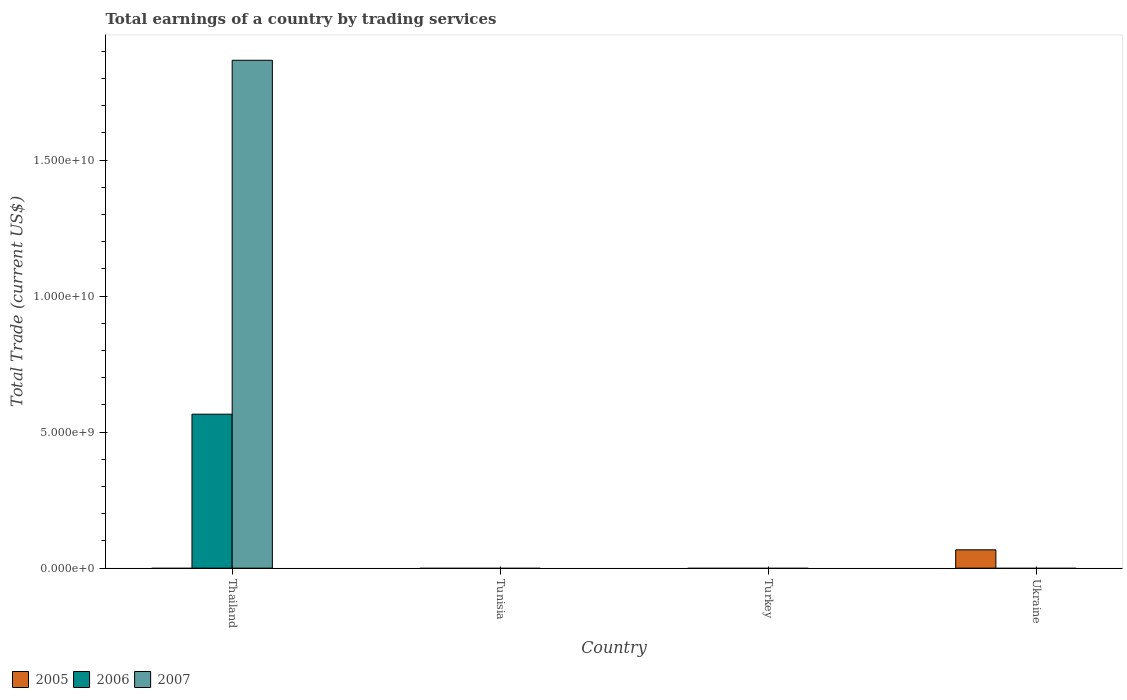How many different coloured bars are there?
Ensure brevity in your answer.  3. Are the number of bars per tick equal to the number of legend labels?
Your response must be concise. No. Are the number of bars on each tick of the X-axis equal?
Keep it short and to the point. No. How many bars are there on the 3rd tick from the left?
Provide a short and direct response. 0. How many bars are there on the 3rd tick from the right?
Your response must be concise. 0. What is the label of the 2nd group of bars from the left?
Your answer should be compact. Tunisia. What is the total earnings in 2005 in Ukraine?
Make the answer very short. 6.74e+08. Across all countries, what is the maximum total earnings in 2007?
Make the answer very short. 1.87e+1. Across all countries, what is the minimum total earnings in 2006?
Ensure brevity in your answer.  0. In which country was the total earnings in 2005 maximum?
Offer a very short reply. Ukraine. What is the total total earnings in 2006 in the graph?
Provide a short and direct response. 5.66e+09. What is the difference between the total earnings in 2005 in Ukraine and the total earnings in 2006 in Turkey?
Provide a short and direct response. 6.74e+08. What is the average total earnings in 2006 per country?
Offer a terse response. 1.42e+09. What is the difference between the highest and the lowest total earnings in 2007?
Make the answer very short. 1.87e+1. In how many countries, is the total earnings in 2006 greater than the average total earnings in 2006 taken over all countries?
Your answer should be very brief. 1. Is it the case that in every country, the sum of the total earnings in 2006 and total earnings in 2007 is greater than the total earnings in 2005?
Your response must be concise. No. How many bars are there?
Keep it short and to the point. 3. Does the graph contain any zero values?
Ensure brevity in your answer.  Yes. Where does the legend appear in the graph?
Provide a short and direct response. Bottom left. How many legend labels are there?
Your answer should be compact. 3. What is the title of the graph?
Provide a succinct answer. Total earnings of a country by trading services. Does "1973" appear as one of the legend labels in the graph?
Offer a terse response. No. What is the label or title of the X-axis?
Ensure brevity in your answer.  Country. What is the label or title of the Y-axis?
Offer a terse response. Total Trade (current US$). What is the Total Trade (current US$) in 2006 in Thailand?
Ensure brevity in your answer.  5.66e+09. What is the Total Trade (current US$) in 2007 in Thailand?
Provide a succinct answer. 1.87e+1. What is the Total Trade (current US$) of 2005 in Tunisia?
Keep it short and to the point. 0. What is the Total Trade (current US$) of 2006 in Tunisia?
Provide a succinct answer. 0. What is the Total Trade (current US$) of 2007 in Turkey?
Provide a short and direct response. 0. What is the Total Trade (current US$) in 2005 in Ukraine?
Your response must be concise. 6.74e+08. Across all countries, what is the maximum Total Trade (current US$) in 2005?
Provide a succinct answer. 6.74e+08. Across all countries, what is the maximum Total Trade (current US$) of 2006?
Ensure brevity in your answer.  5.66e+09. Across all countries, what is the maximum Total Trade (current US$) of 2007?
Provide a succinct answer. 1.87e+1. Across all countries, what is the minimum Total Trade (current US$) of 2005?
Provide a succinct answer. 0. Across all countries, what is the minimum Total Trade (current US$) of 2006?
Your answer should be very brief. 0. Across all countries, what is the minimum Total Trade (current US$) of 2007?
Provide a short and direct response. 0. What is the total Total Trade (current US$) in 2005 in the graph?
Your answer should be very brief. 6.74e+08. What is the total Total Trade (current US$) of 2006 in the graph?
Offer a very short reply. 5.66e+09. What is the total Total Trade (current US$) in 2007 in the graph?
Provide a succinct answer. 1.87e+1. What is the average Total Trade (current US$) in 2005 per country?
Your answer should be compact. 1.68e+08. What is the average Total Trade (current US$) of 2006 per country?
Offer a very short reply. 1.42e+09. What is the average Total Trade (current US$) in 2007 per country?
Ensure brevity in your answer.  4.67e+09. What is the difference between the Total Trade (current US$) in 2006 and Total Trade (current US$) in 2007 in Thailand?
Your answer should be very brief. -1.30e+1. What is the difference between the highest and the lowest Total Trade (current US$) of 2005?
Offer a terse response. 6.74e+08. What is the difference between the highest and the lowest Total Trade (current US$) of 2006?
Make the answer very short. 5.66e+09. What is the difference between the highest and the lowest Total Trade (current US$) in 2007?
Offer a terse response. 1.87e+1. 